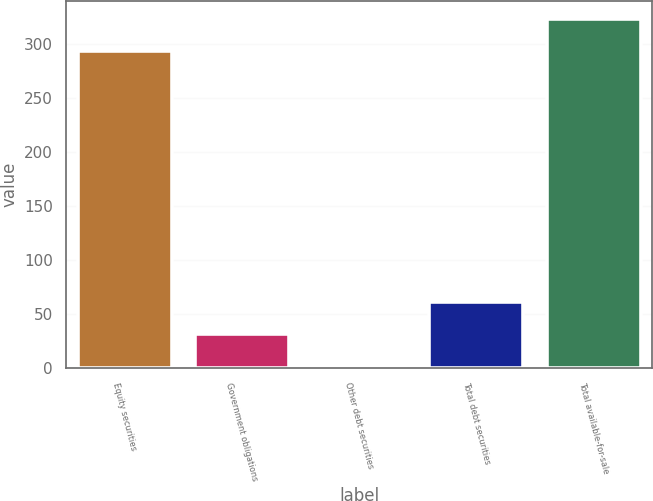Convert chart. <chart><loc_0><loc_0><loc_500><loc_500><bar_chart><fcel>Equity securities<fcel>Government obligations<fcel>Other debt securities<fcel>Total debt securities<fcel>Total available-for-sale<nl><fcel>294<fcel>31.8<fcel>2<fcel>61.6<fcel>323.8<nl></chart> 